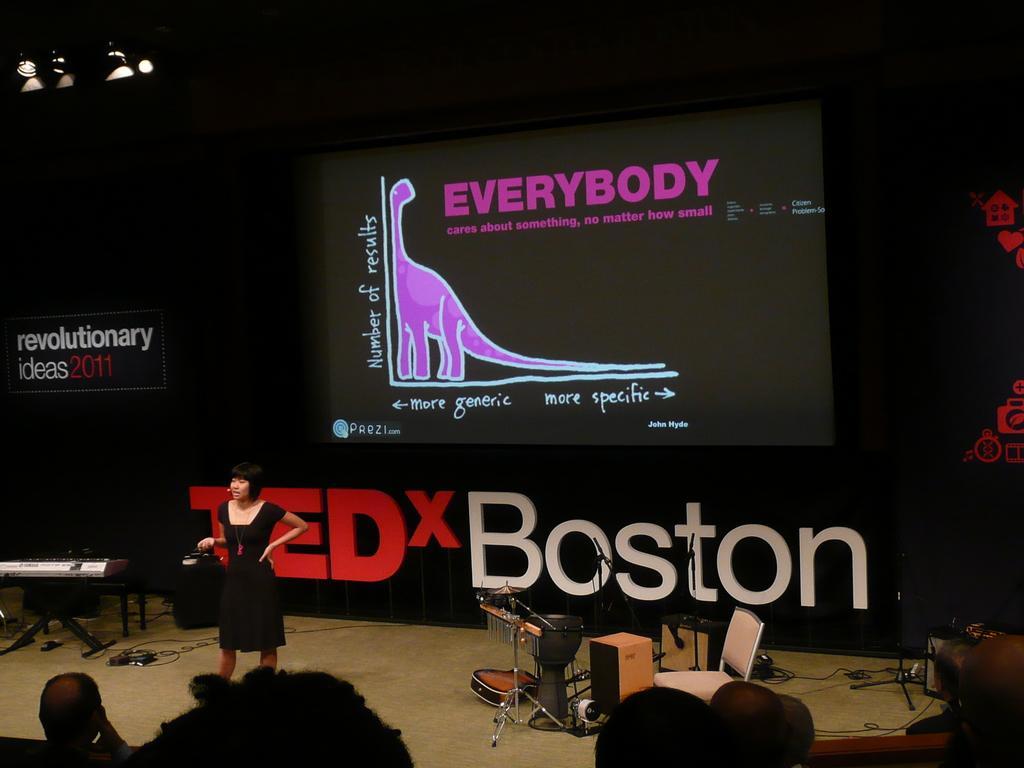Describe this image in one or two sentences. In this image we can see a woman wearing black dress is standing on stage. On the right side of the image we can see group of musical instruments and a chair placed on the floor. In the foreground we can see group of persons. In the background, we can a screen and some text. 